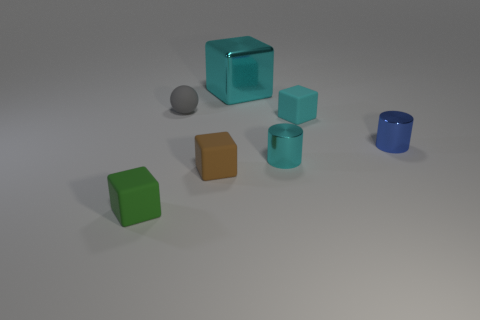What number of other objects are there of the same material as the green object?
Ensure brevity in your answer.  3. There is a tiny metallic object that is in front of the blue metallic thing; is its color the same as the cube that is behind the gray thing?
Ensure brevity in your answer.  Yes. What is the shape of the tiny rubber thing that is behind the tiny cube behind the small cyan shiny object?
Give a very brief answer. Sphere. How many other things are there of the same color as the tiny sphere?
Ensure brevity in your answer.  0. Does the small object to the right of the tiny cyan cube have the same material as the tiny cylinder on the left side of the cyan rubber thing?
Your answer should be very brief. Yes. There is a brown cube in front of the big block; what size is it?
Make the answer very short. Small. What material is the large cyan thing that is the same shape as the tiny green object?
Your answer should be very brief. Metal. Are there any other things that are the same size as the metallic block?
Provide a succinct answer. No. The cyan metal thing that is behind the gray object has what shape?
Your answer should be very brief. Cube. What number of green rubber objects are the same shape as the small brown rubber object?
Give a very brief answer. 1. 